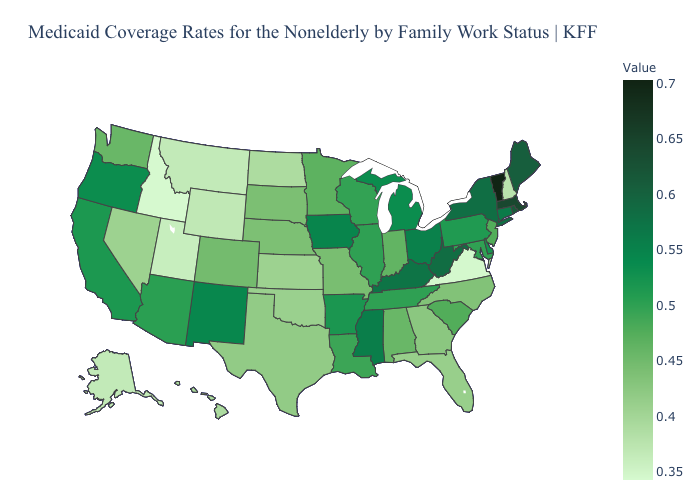Does Vermont have the highest value in the USA?
Quick response, please. Yes. Which states have the lowest value in the West?
Concise answer only. Idaho. Does the map have missing data?
Short answer required. No. Does the map have missing data?
Write a very short answer. No. Does Illinois have a higher value than Nevada?
Concise answer only. Yes. Does New York have the lowest value in the Northeast?
Give a very brief answer. No. 